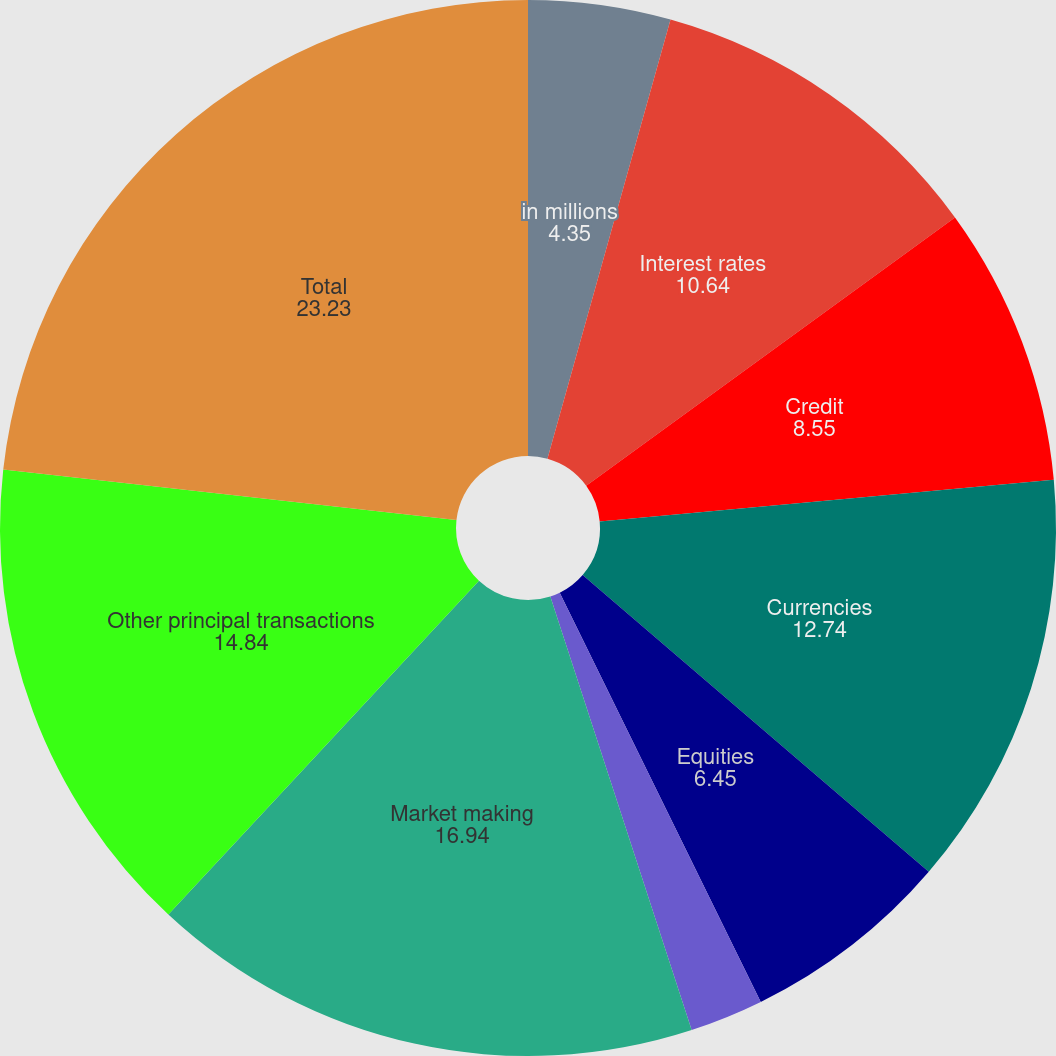Convert chart. <chart><loc_0><loc_0><loc_500><loc_500><pie_chart><fcel>in millions<fcel>Interest rates<fcel>Credit<fcel>Currencies<fcel>Equities<fcel>Commodities<fcel>Market making<fcel>Other principal transactions<fcel>Total<nl><fcel>4.35%<fcel>10.64%<fcel>8.55%<fcel>12.74%<fcel>6.45%<fcel>2.25%<fcel>16.94%<fcel>14.84%<fcel>23.23%<nl></chart> 